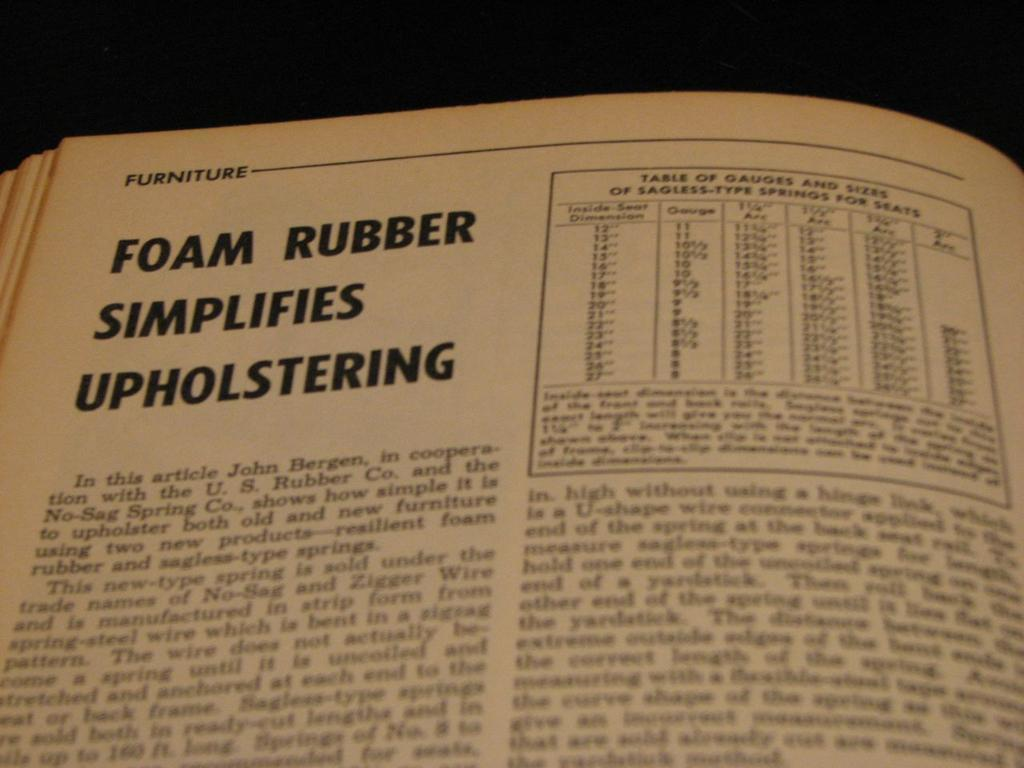<image>
Give a short and clear explanation of the subsequent image. open book on the page of foam rubber simplifies 